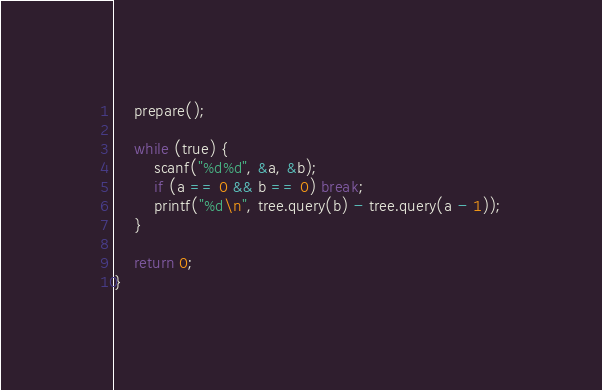Convert code to text. <code><loc_0><loc_0><loc_500><loc_500><_C++_>    prepare();

    while (true) {
        scanf("%d%d", &a, &b);
        if (a == 0 && b == 0) break;
        printf("%d\n", tree.query(b) - tree.query(a - 1));
    }

    return 0;
}
</code> 